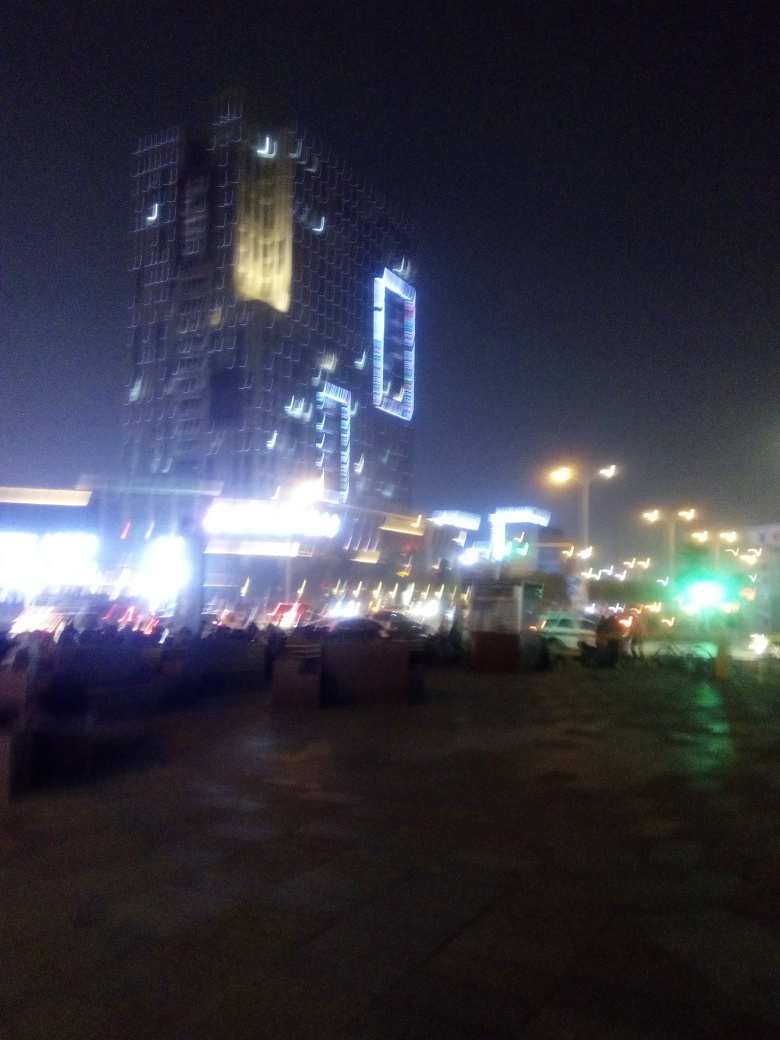What might be the significance of the lit-up building in the image? The prominently lit building seems to be a focal point, possibly a landmark or a centerpiece of the district. Its illumination signifies importance, suggesting it could be a major commercial or cultural hub within the cityscape. 